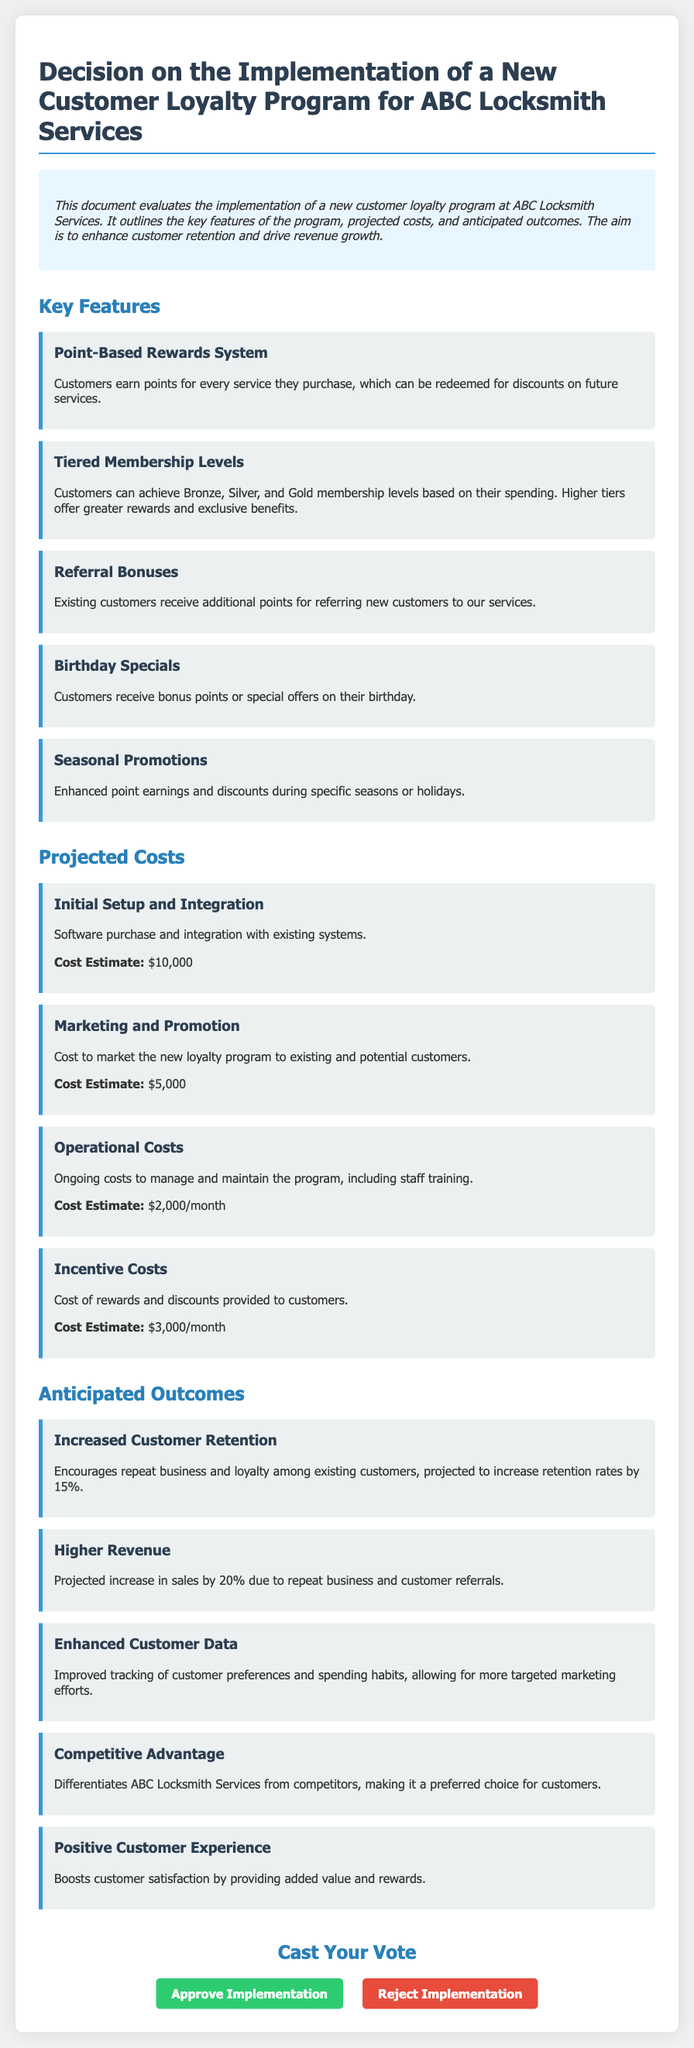What is the initial setup cost for the loyalty program? The initial setup cost is listed in the document under Projected Costs as the cost for software purchase and integration.
Answer: $10,000 How much does the loyalty program aim to increase customer retention? The document states the projected increase in customer retention rates as part of the anticipated outcomes section.
Answer: 15% What is one benefit of tiered membership levels? The document describes that higher tiers offer greater rewards and exclusive benefits under key features.
Answer: Greater rewards What is the projected increase in sales due to the loyalty program? The document indicates a projected increase in sales due to repeat business and customer referrals in the anticipated outcomes section.
Answer: 20% What is the monthly operational cost for managing the program? The operational costs are explained in the Projected Costs section, specifying costs for management and maintenance including staff training.
Answer: $2,000/month What special offer is given to customers on their birthday? The birthday specials are mentioned in the key features of the loyalty program, highlighting bonus points or special offers.
Answer: Bonus points What do referral bonuses provide customers? The document indicates that existing customers receive additional points for referring new customers as part of the key features.
Answer: Additional points What color is used for the vote approval button? The vote approval button's color is described in the style section of the document.
Answer: Green What type of program is being discussed in the document? The document specifically outlines the implementation of a program aimed at enhancing customer retention and driving revenue growth.
Answer: Customer loyalty program 